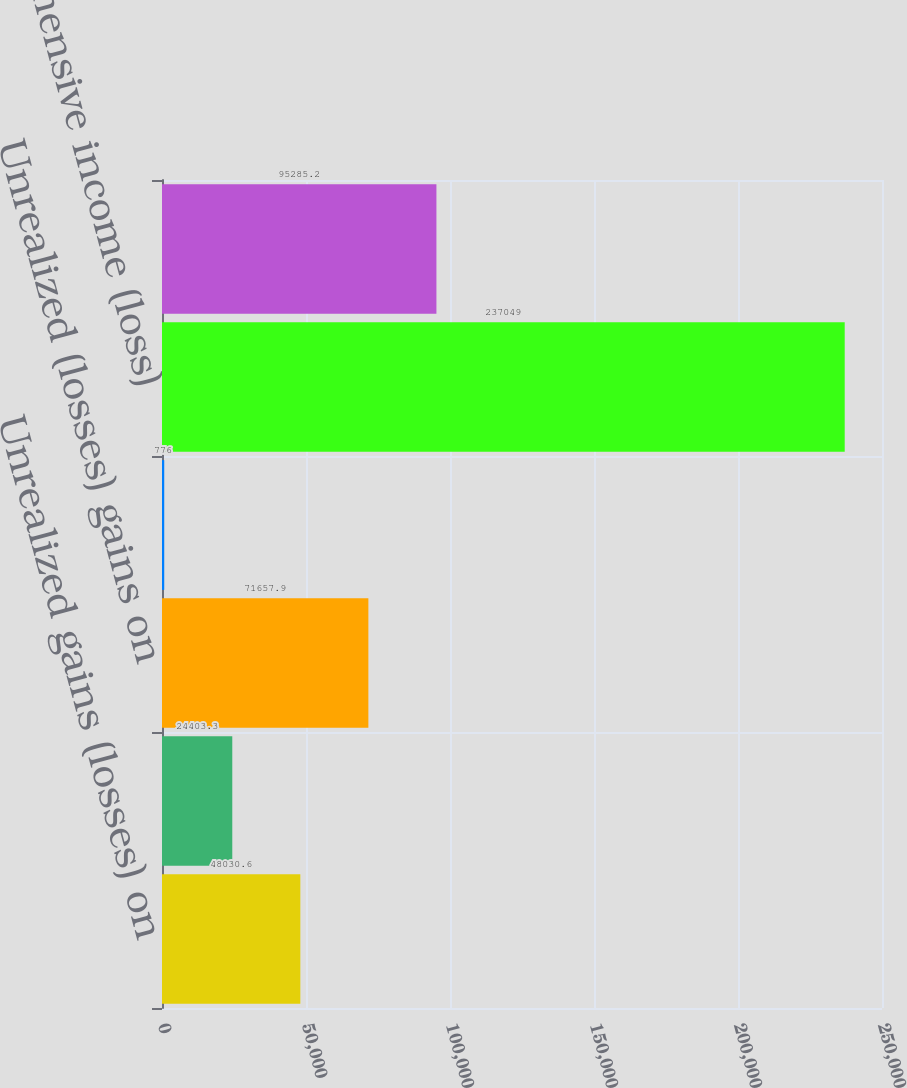Convert chart. <chart><loc_0><loc_0><loc_500><loc_500><bar_chart><fcel>Unrealized gains (losses) on<fcel>Losses on interest rate swaps<fcel>Unrealized (losses) gains on<fcel>Other comprehensive (loss)<fcel>Comprehensive income (loss)<fcel>Comprehensive (income) loss<nl><fcel>48030.6<fcel>24403.3<fcel>71657.9<fcel>776<fcel>237049<fcel>95285.2<nl></chart> 